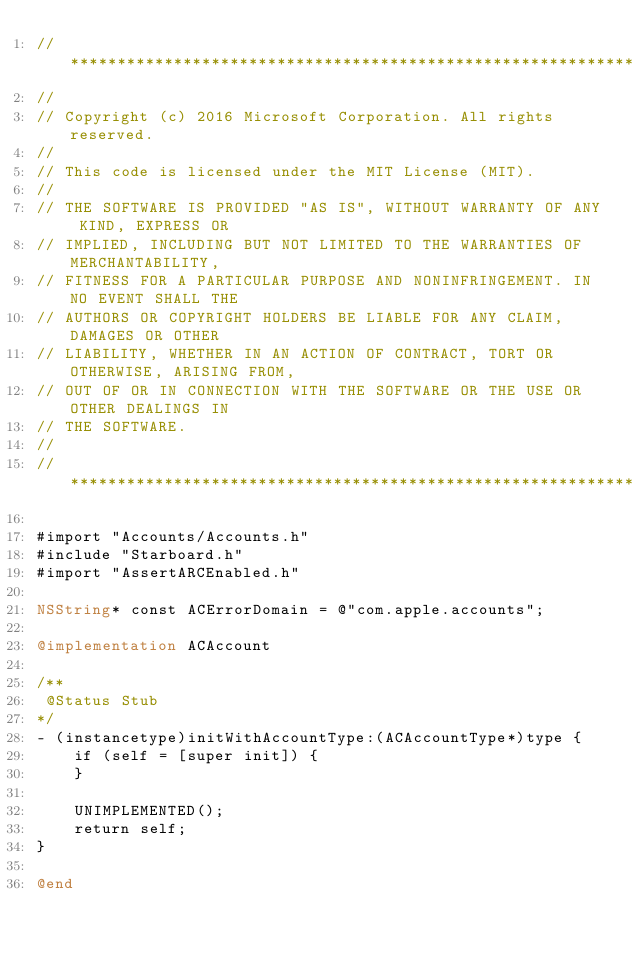Convert code to text. <code><loc_0><loc_0><loc_500><loc_500><_ObjectiveC_>//******************************************************************************
//
// Copyright (c) 2016 Microsoft Corporation. All rights reserved.
//
// This code is licensed under the MIT License (MIT).
//
// THE SOFTWARE IS PROVIDED "AS IS", WITHOUT WARRANTY OF ANY KIND, EXPRESS OR
// IMPLIED, INCLUDING BUT NOT LIMITED TO THE WARRANTIES OF MERCHANTABILITY,
// FITNESS FOR A PARTICULAR PURPOSE AND NONINFRINGEMENT. IN NO EVENT SHALL THE
// AUTHORS OR COPYRIGHT HOLDERS BE LIABLE FOR ANY CLAIM, DAMAGES OR OTHER
// LIABILITY, WHETHER IN AN ACTION OF CONTRACT, TORT OR OTHERWISE, ARISING FROM,
// OUT OF OR IN CONNECTION WITH THE SOFTWARE OR THE USE OR OTHER DEALINGS IN
// THE SOFTWARE.
//
//******************************************************************************

#import "Accounts/Accounts.h"
#include "Starboard.h"
#import "AssertARCEnabled.h"

NSString* const ACErrorDomain = @"com.apple.accounts";

@implementation ACAccount

/**
 @Status Stub
*/
- (instancetype)initWithAccountType:(ACAccountType*)type {
    if (self = [super init]) {
    }

    UNIMPLEMENTED();
    return self;
}

@end</code> 